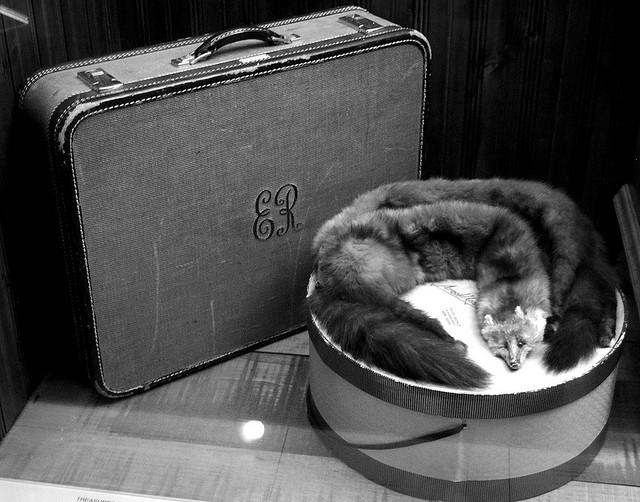Is the animal on the hat box asleep?
Quick response, please. No. Is the picture taken in black and white?
Keep it brief. Yes. What initials are on the suitcase?
Keep it brief. Er. 